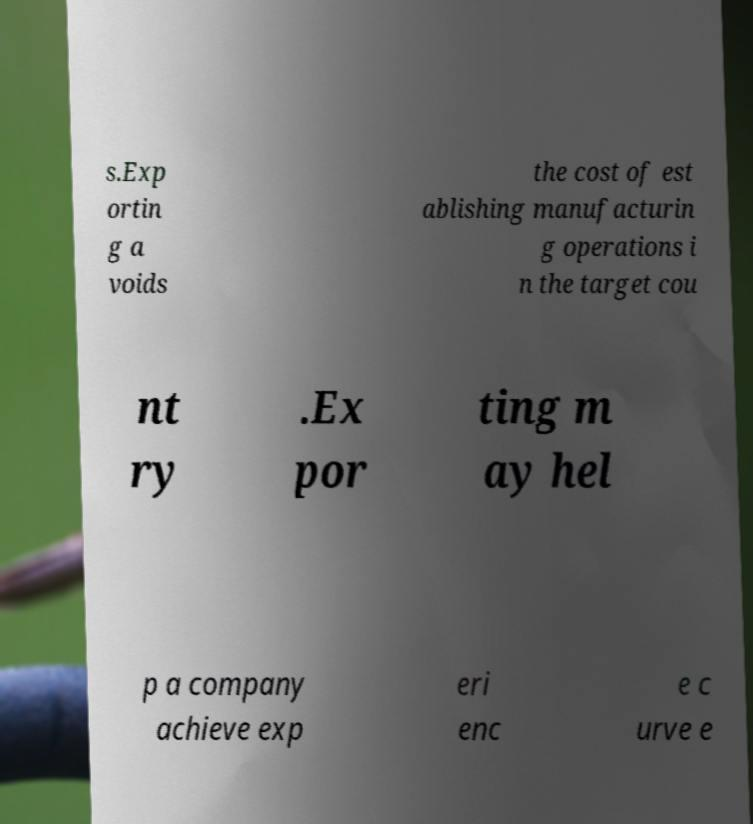Can you read and provide the text displayed in the image?This photo seems to have some interesting text. Can you extract and type it out for me? s.Exp ortin g a voids the cost of est ablishing manufacturin g operations i n the target cou nt ry .Ex por ting m ay hel p a company achieve exp eri enc e c urve e 